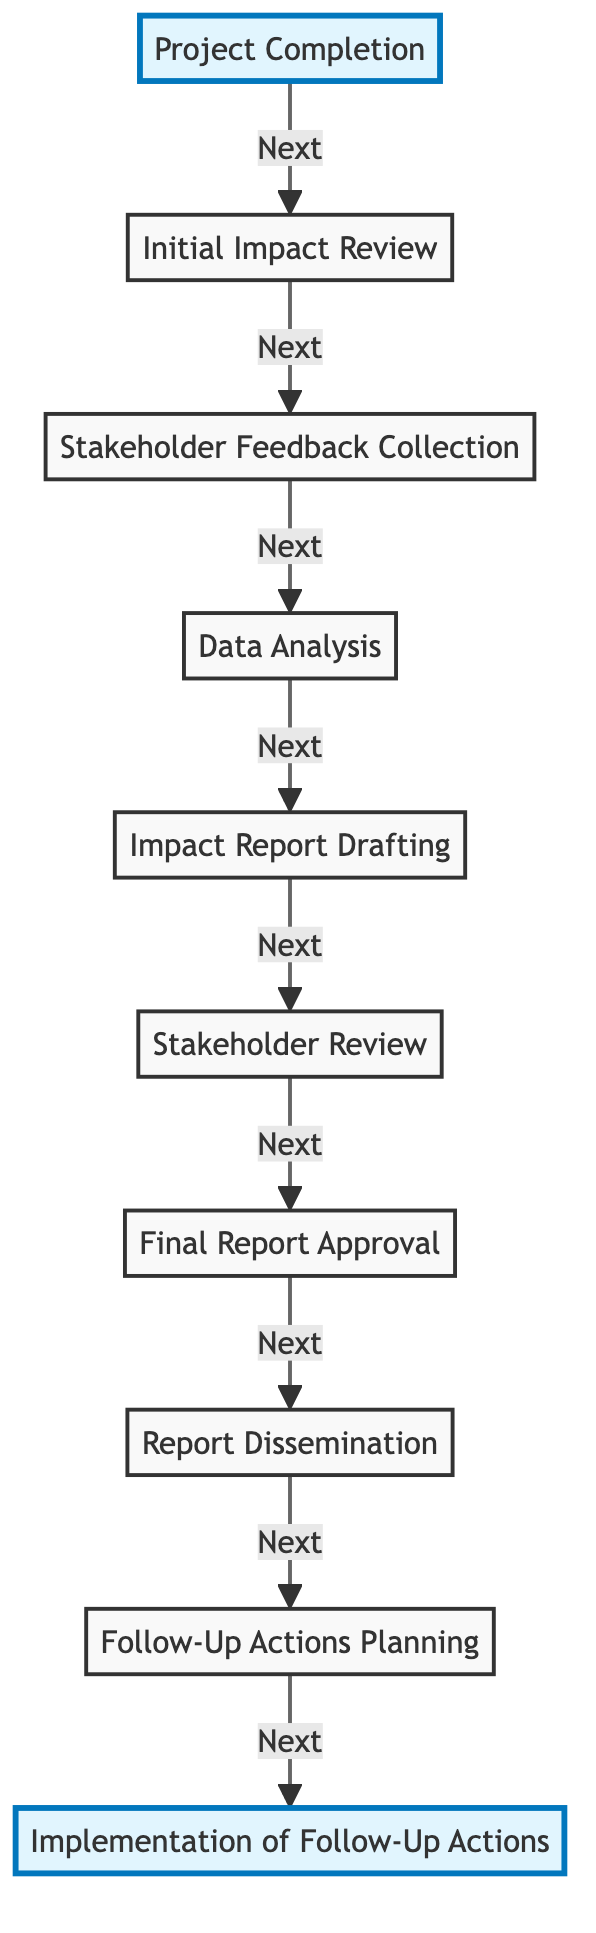What is the first step after project completion? The diagram flows from "Project Completion" to "Initial Impact Review" which indicates that the first step after project completion is to conduct this review.
Answer: Initial Impact Review How many nodes are present in the diagram? The diagram lists 10 nodes, each representing a specific step in the post-project impact assessment process.
Answer: 10 What is the final step in the flow chart? The flow chart concludes with the node "Implementation of Follow-Up Actions," indicating it is the last step of the process.
Answer: Implementation of Follow-Up Actions What is the primary purpose of the "Data Analysis" step? The purpose of the "Data Analysis" step is to evaluate the social impact using quantitative and qualitative methods, as described in that node.
Answer: Evaluate social impact Which node indicates the approval of the final report? The node "Final Report Approval" signifies the internal approval process for the final impact report, as shown in the flow.
Answer: Final Report Approval What do the highlighted nodes in the flow chart represent? The highlighted nodes "Project Completion" and "Implementation of Follow-Up Actions" signify the start and the conclusion of the assessment process, marking key positions in the flow.
Answer: Start and conclusion What is the path from "Stakeholder Feedback Collection" to "Report Dissemination"? The path proceeds from "Stakeholder Feedback Collection" to "Data Analysis," then to "Impact Report Drafting," followed by "Stakeholder Review," "Final Report Approval," and finally leads to "Report Dissemination."
Answer: Stakeholder Feedback Collection → Data Analysis → Impact Report Drafting → Stakeholder Review → Final Report Approval → Report Dissemination Which step comes immediately before "Follow-Up Actions Planning"? The step that precedes "Follow-Up Actions Planning" is "Report Dissemination," as indicated in the diagram.
Answer: Report Dissemination How is stakeholder review represented in the diagram? "Stakeholder Review" is represented as a key step that follows "Impact Report Drafting" and is crucial for collecting input on the draft report.
Answer: Stakeholder Review 